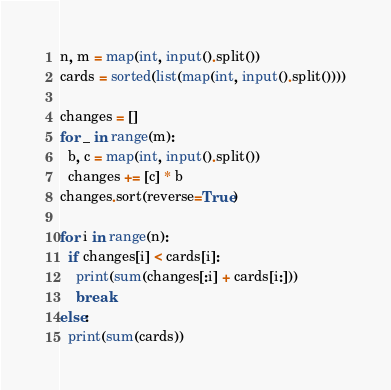Convert code to text. <code><loc_0><loc_0><loc_500><loc_500><_Python_>n, m = map(int, input().split())
cards = sorted(list(map(int, input().split())))

changes = []
for _ in range(m):
  b, c = map(int, input().split())
  changes += [c] * b
changes.sort(reverse=True)

for i in range(n):
  if changes[i] < cards[i]:
    print(sum(changes[:i] + cards[i:]))
    break
else:
  print(sum(cards))</code> 